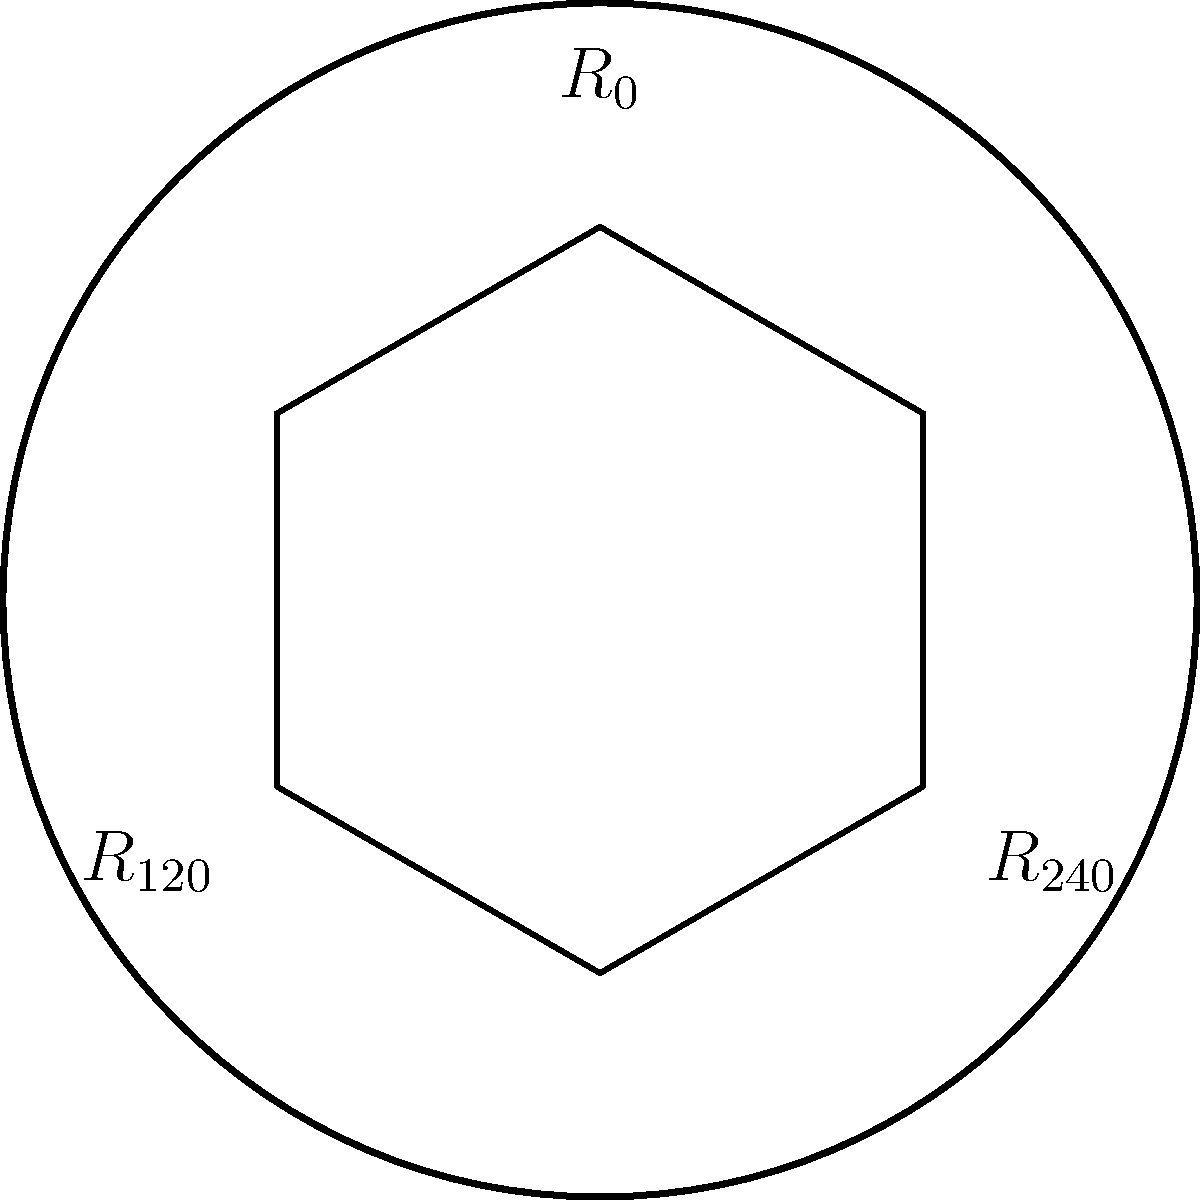A samurai sword guard (tsuba) has a symmetrical design as shown in the figure. The design can be rotated by 120° and 240° to create identical configurations. How many elements are in the rotation group of this tsuba, and what is the group isomorphic to? Let's approach this step-by-step:

1) First, we need to identify all the rotations that leave the design unchanged:
   - $R_0$: No rotation (identity)
   - $R_{120}$: Rotation by 120°
   - $R_{240}$: Rotation by 240°

2) These rotations form a group under composition. Let's verify:
   - The identity element $R_0$ exists
   - Each element has an inverse:
     $R_0^{-1} = R_0$
     $R_{120}^{-1} = R_{240}$
     $R_{240}^{-1} = R_{120}$
   - The group is closed under composition and associative

3) The number of elements in this group is 3.

4) To determine what this group is isomorphic to, we need to consider cyclic groups:
   - This group has 3 elements
   - $R_{120} \circ R_{120} = R_{240}$
   - $R_{120} \circ R_{120} \circ R_{120} = R_0$

5) This behavior is identical to the cyclic group of order 3, denoted as $C_3$ or $\mathbb{Z}/3\mathbb{Z}$.

Therefore, the rotation group of this tsuba has 3 elements and is isomorphic to $C_3$.
Answer: 3 elements; isomorphic to $C_3$ 